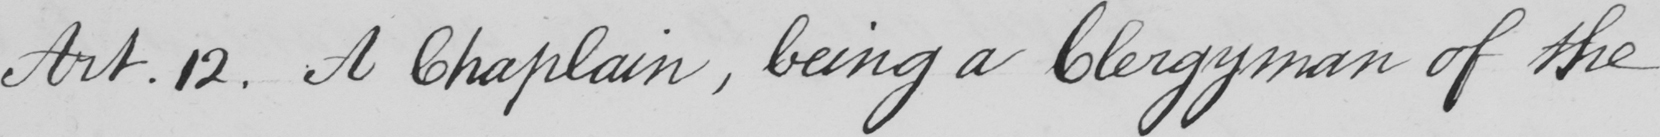Can you read and transcribe this handwriting? Art.12 . A Chaplain , being a clergyman of the 